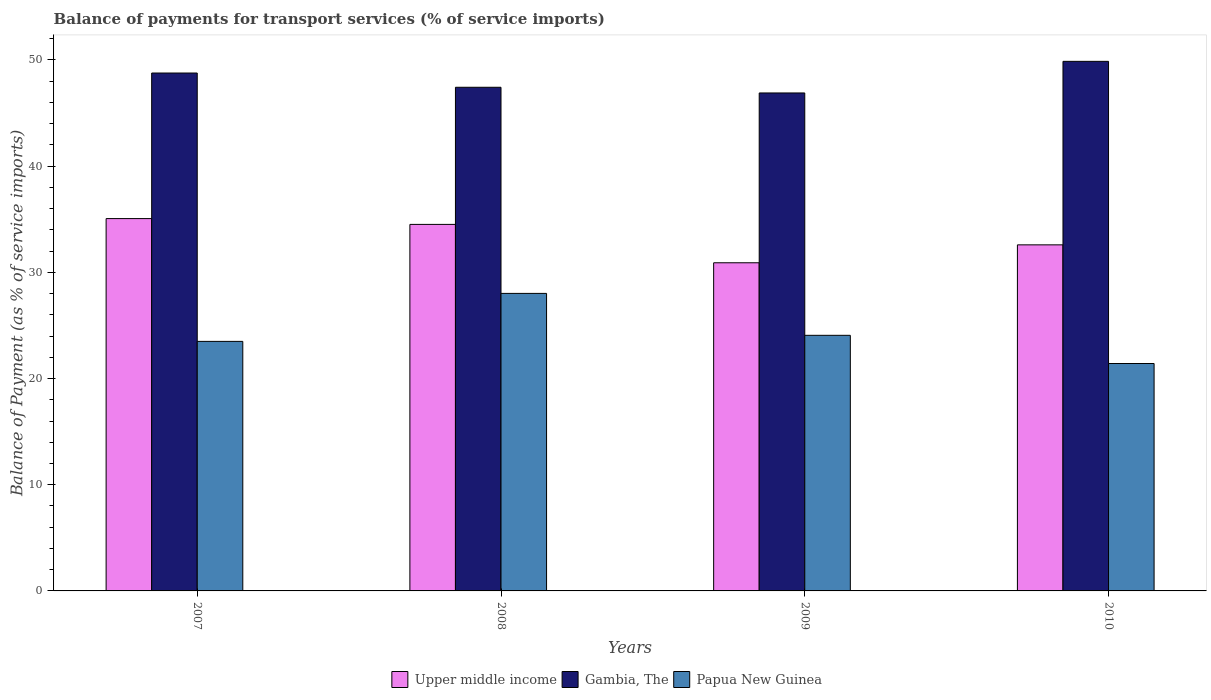How many groups of bars are there?
Offer a very short reply. 4. Are the number of bars per tick equal to the number of legend labels?
Ensure brevity in your answer.  Yes. How many bars are there on the 2nd tick from the left?
Ensure brevity in your answer.  3. What is the balance of payments for transport services in Upper middle income in 2007?
Give a very brief answer. 35.06. Across all years, what is the maximum balance of payments for transport services in Gambia, The?
Keep it short and to the point. 49.87. Across all years, what is the minimum balance of payments for transport services in Gambia, The?
Give a very brief answer. 46.89. In which year was the balance of payments for transport services in Upper middle income minimum?
Keep it short and to the point. 2009. What is the total balance of payments for transport services in Papua New Guinea in the graph?
Ensure brevity in your answer.  97. What is the difference between the balance of payments for transport services in Papua New Guinea in 2007 and that in 2010?
Give a very brief answer. 2.08. What is the difference between the balance of payments for transport services in Upper middle income in 2008 and the balance of payments for transport services in Gambia, The in 2007?
Provide a short and direct response. -14.25. What is the average balance of payments for transport services in Gambia, The per year?
Give a very brief answer. 48.24. In the year 2010, what is the difference between the balance of payments for transport services in Upper middle income and balance of payments for transport services in Gambia, The?
Ensure brevity in your answer.  -17.28. In how many years, is the balance of payments for transport services in Papua New Guinea greater than 42 %?
Make the answer very short. 0. What is the ratio of the balance of payments for transport services in Gambia, The in 2009 to that in 2010?
Keep it short and to the point. 0.94. Is the balance of payments for transport services in Upper middle income in 2007 less than that in 2008?
Offer a terse response. No. What is the difference between the highest and the second highest balance of payments for transport services in Upper middle income?
Keep it short and to the point. 0.55. What is the difference between the highest and the lowest balance of payments for transport services in Upper middle income?
Keep it short and to the point. 4.16. In how many years, is the balance of payments for transport services in Gambia, The greater than the average balance of payments for transport services in Gambia, The taken over all years?
Your answer should be very brief. 2. What does the 3rd bar from the left in 2010 represents?
Keep it short and to the point. Papua New Guinea. What does the 3rd bar from the right in 2008 represents?
Provide a short and direct response. Upper middle income. Is it the case that in every year, the sum of the balance of payments for transport services in Upper middle income and balance of payments for transport services in Gambia, The is greater than the balance of payments for transport services in Papua New Guinea?
Your response must be concise. Yes. How many bars are there?
Provide a succinct answer. 12. Are all the bars in the graph horizontal?
Your response must be concise. No. How many years are there in the graph?
Give a very brief answer. 4. Are the values on the major ticks of Y-axis written in scientific E-notation?
Make the answer very short. No. Where does the legend appear in the graph?
Offer a very short reply. Bottom center. How many legend labels are there?
Offer a very short reply. 3. What is the title of the graph?
Ensure brevity in your answer.  Balance of payments for transport services (% of service imports). Does "Suriname" appear as one of the legend labels in the graph?
Make the answer very short. No. What is the label or title of the Y-axis?
Your response must be concise. Balance of Payment (as % of service imports). What is the Balance of Payment (as % of service imports) of Upper middle income in 2007?
Give a very brief answer. 35.06. What is the Balance of Payment (as % of service imports) in Gambia, The in 2007?
Your response must be concise. 48.77. What is the Balance of Payment (as % of service imports) of Papua New Guinea in 2007?
Your answer should be compact. 23.5. What is the Balance of Payment (as % of service imports) in Upper middle income in 2008?
Make the answer very short. 34.51. What is the Balance of Payment (as % of service imports) of Gambia, The in 2008?
Offer a very short reply. 47.43. What is the Balance of Payment (as % of service imports) of Papua New Guinea in 2008?
Keep it short and to the point. 28.02. What is the Balance of Payment (as % of service imports) of Upper middle income in 2009?
Your answer should be very brief. 30.9. What is the Balance of Payment (as % of service imports) in Gambia, The in 2009?
Ensure brevity in your answer.  46.89. What is the Balance of Payment (as % of service imports) in Papua New Guinea in 2009?
Make the answer very short. 24.07. What is the Balance of Payment (as % of service imports) in Upper middle income in 2010?
Provide a succinct answer. 32.59. What is the Balance of Payment (as % of service imports) in Gambia, The in 2010?
Offer a terse response. 49.87. What is the Balance of Payment (as % of service imports) in Papua New Guinea in 2010?
Offer a terse response. 21.41. Across all years, what is the maximum Balance of Payment (as % of service imports) of Upper middle income?
Your answer should be compact. 35.06. Across all years, what is the maximum Balance of Payment (as % of service imports) in Gambia, The?
Your response must be concise. 49.87. Across all years, what is the maximum Balance of Payment (as % of service imports) in Papua New Guinea?
Your answer should be very brief. 28.02. Across all years, what is the minimum Balance of Payment (as % of service imports) of Upper middle income?
Offer a very short reply. 30.9. Across all years, what is the minimum Balance of Payment (as % of service imports) in Gambia, The?
Provide a succinct answer. 46.89. Across all years, what is the minimum Balance of Payment (as % of service imports) in Papua New Guinea?
Give a very brief answer. 21.41. What is the total Balance of Payment (as % of service imports) in Upper middle income in the graph?
Your answer should be compact. 133.06. What is the total Balance of Payment (as % of service imports) in Gambia, The in the graph?
Provide a short and direct response. 192.95. What is the total Balance of Payment (as % of service imports) in Papua New Guinea in the graph?
Make the answer very short. 97. What is the difference between the Balance of Payment (as % of service imports) of Upper middle income in 2007 and that in 2008?
Ensure brevity in your answer.  0.55. What is the difference between the Balance of Payment (as % of service imports) of Gambia, The in 2007 and that in 2008?
Keep it short and to the point. 1.34. What is the difference between the Balance of Payment (as % of service imports) in Papua New Guinea in 2007 and that in 2008?
Provide a succinct answer. -4.52. What is the difference between the Balance of Payment (as % of service imports) of Upper middle income in 2007 and that in 2009?
Offer a terse response. 4.16. What is the difference between the Balance of Payment (as % of service imports) in Gambia, The in 2007 and that in 2009?
Your answer should be very brief. 1.88. What is the difference between the Balance of Payment (as % of service imports) in Papua New Guinea in 2007 and that in 2009?
Offer a very short reply. -0.57. What is the difference between the Balance of Payment (as % of service imports) of Upper middle income in 2007 and that in 2010?
Make the answer very short. 2.47. What is the difference between the Balance of Payment (as % of service imports) of Gambia, The in 2007 and that in 2010?
Give a very brief answer. -1.1. What is the difference between the Balance of Payment (as % of service imports) of Papua New Guinea in 2007 and that in 2010?
Make the answer very short. 2.08. What is the difference between the Balance of Payment (as % of service imports) in Upper middle income in 2008 and that in 2009?
Offer a terse response. 3.61. What is the difference between the Balance of Payment (as % of service imports) of Gambia, The in 2008 and that in 2009?
Keep it short and to the point. 0.54. What is the difference between the Balance of Payment (as % of service imports) of Papua New Guinea in 2008 and that in 2009?
Ensure brevity in your answer.  3.95. What is the difference between the Balance of Payment (as % of service imports) of Upper middle income in 2008 and that in 2010?
Offer a terse response. 1.93. What is the difference between the Balance of Payment (as % of service imports) in Gambia, The in 2008 and that in 2010?
Keep it short and to the point. -2.44. What is the difference between the Balance of Payment (as % of service imports) of Papua New Guinea in 2008 and that in 2010?
Your response must be concise. 6.6. What is the difference between the Balance of Payment (as % of service imports) in Upper middle income in 2009 and that in 2010?
Your response must be concise. -1.69. What is the difference between the Balance of Payment (as % of service imports) in Gambia, The in 2009 and that in 2010?
Your response must be concise. -2.98. What is the difference between the Balance of Payment (as % of service imports) in Papua New Guinea in 2009 and that in 2010?
Give a very brief answer. 2.65. What is the difference between the Balance of Payment (as % of service imports) in Upper middle income in 2007 and the Balance of Payment (as % of service imports) in Gambia, The in 2008?
Your answer should be compact. -12.37. What is the difference between the Balance of Payment (as % of service imports) in Upper middle income in 2007 and the Balance of Payment (as % of service imports) in Papua New Guinea in 2008?
Provide a short and direct response. 7.04. What is the difference between the Balance of Payment (as % of service imports) in Gambia, The in 2007 and the Balance of Payment (as % of service imports) in Papua New Guinea in 2008?
Keep it short and to the point. 20.75. What is the difference between the Balance of Payment (as % of service imports) of Upper middle income in 2007 and the Balance of Payment (as % of service imports) of Gambia, The in 2009?
Offer a terse response. -11.83. What is the difference between the Balance of Payment (as % of service imports) in Upper middle income in 2007 and the Balance of Payment (as % of service imports) in Papua New Guinea in 2009?
Your answer should be compact. 10.99. What is the difference between the Balance of Payment (as % of service imports) in Gambia, The in 2007 and the Balance of Payment (as % of service imports) in Papua New Guinea in 2009?
Make the answer very short. 24.7. What is the difference between the Balance of Payment (as % of service imports) of Upper middle income in 2007 and the Balance of Payment (as % of service imports) of Gambia, The in 2010?
Provide a succinct answer. -14.81. What is the difference between the Balance of Payment (as % of service imports) of Upper middle income in 2007 and the Balance of Payment (as % of service imports) of Papua New Guinea in 2010?
Provide a short and direct response. 13.65. What is the difference between the Balance of Payment (as % of service imports) in Gambia, The in 2007 and the Balance of Payment (as % of service imports) in Papua New Guinea in 2010?
Make the answer very short. 27.35. What is the difference between the Balance of Payment (as % of service imports) of Upper middle income in 2008 and the Balance of Payment (as % of service imports) of Gambia, The in 2009?
Your answer should be compact. -12.38. What is the difference between the Balance of Payment (as % of service imports) of Upper middle income in 2008 and the Balance of Payment (as % of service imports) of Papua New Guinea in 2009?
Provide a short and direct response. 10.45. What is the difference between the Balance of Payment (as % of service imports) in Gambia, The in 2008 and the Balance of Payment (as % of service imports) in Papua New Guinea in 2009?
Your answer should be compact. 23.36. What is the difference between the Balance of Payment (as % of service imports) of Upper middle income in 2008 and the Balance of Payment (as % of service imports) of Gambia, The in 2010?
Offer a very short reply. -15.35. What is the difference between the Balance of Payment (as % of service imports) in Upper middle income in 2008 and the Balance of Payment (as % of service imports) in Papua New Guinea in 2010?
Your response must be concise. 13.1. What is the difference between the Balance of Payment (as % of service imports) in Gambia, The in 2008 and the Balance of Payment (as % of service imports) in Papua New Guinea in 2010?
Your answer should be compact. 26.01. What is the difference between the Balance of Payment (as % of service imports) of Upper middle income in 2009 and the Balance of Payment (as % of service imports) of Gambia, The in 2010?
Keep it short and to the point. -18.97. What is the difference between the Balance of Payment (as % of service imports) of Upper middle income in 2009 and the Balance of Payment (as % of service imports) of Papua New Guinea in 2010?
Your answer should be compact. 9.49. What is the difference between the Balance of Payment (as % of service imports) in Gambia, The in 2009 and the Balance of Payment (as % of service imports) in Papua New Guinea in 2010?
Give a very brief answer. 25.48. What is the average Balance of Payment (as % of service imports) of Upper middle income per year?
Ensure brevity in your answer.  33.27. What is the average Balance of Payment (as % of service imports) of Gambia, The per year?
Offer a very short reply. 48.24. What is the average Balance of Payment (as % of service imports) in Papua New Guinea per year?
Provide a succinct answer. 24.25. In the year 2007, what is the difference between the Balance of Payment (as % of service imports) in Upper middle income and Balance of Payment (as % of service imports) in Gambia, The?
Your response must be concise. -13.71. In the year 2007, what is the difference between the Balance of Payment (as % of service imports) in Upper middle income and Balance of Payment (as % of service imports) in Papua New Guinea?
Offer a terse response. 11.56. In the year 2007, what is the difference between the Balance of Payment (as % of service imports) of Gambia, The and Balance of Payment (as % of service imports) of Papua New Guinea?
Make the answer very short. 25.27. In the year 2008, what is the difference between the Balance of Payment (as % of service imports) of Upper middle income and Balance of Payment (as % of service imports) of Gambia, The?
Provide a succinct answer. -12.91. In the year 2008, what is the difference between the Balance of Payment (as % of service imports) of Upper middle income and Balance of Payment (as % of service imports) of Papua New Guinea?
Your answer should be very brief. 6.5. In the year 2008, what is the difference between the Balance of Payment (as % of service imports) of Gambia, The and Balance of Payment (as % of service imports) of Papua New Guinea?
Your answer should be compact. 19.41. In the year 2009, what is the difference between the Balance of Payment (as % of service imports) of Upper middle income and Balance of Payment (as % of service imports) of Gambia, The?
Your answer should be very brief. -15.99. In the year 2009, what is the difference between the Balance of Payment (as % of service imports) of Upper middle income and Balance of Payment (as % of service imports) of Papua New Guinea?
Your response must be concise. 6.83. In the year 2009, what is the difference between the Balance of Payment (as % of service imports) in Gambia, The and Balance of Payment (as % of service imports) in Papua New Guinea?
Ensure brevity in your answer.  22.82. In the year 2010, what is the difference between the Balance of Payment (as % of service imports) in Upper middle income and Balance of Payment (as % of service imports) in Gambia, The?
Provide a succinct answer. -17.28. In the year 2010, what is the difference between the Balance of Payment (as % of service imports) of Upper middle income and Balance of Payment (as % of service imports) of Papua New Guinea?
Give a very brief answer. 11.17. In the year 2010, what is the difference between the Balance of Payment (as % of service imports) of Gambia, The and Balance of Payment (as % of service imports) of Papua New Guinea?
Your response must be concise. 28.45. What is the ratio of the Balance of Payment (as % of service imports) in Upper middle income in 2007 to that in 2008?
Provide a succinct answer. 1.02. What is the ratio of the Balance of Payment (as % of service imports) in Gambia, The in 2007 to that in 2008?
Your answer should be compact. 1.03. What is the ratio of the Balance of Payment (as % of service imports) of Papua New Guinea in 2007 to that in 2008?
Provide a succinct answer. 0.84. What is the ratio of the Balance of Payment (as % of service imports) of Upper middle income in 2007 to that in 2009?
Offer a terse response. 1.13. What is the ratio of the Balance of Payment (as % of service imports) in Papua New Guinea in 2007 to that in 2009?
Offer a terse response. 0.98. What is the ratio of the Balance of Payment (as % of service imports) of Upper middle income in 2007 to that in 2010?
Your answer should be compact. 1.08. What is the ratio of the Balance of Payment (as % of service imports) in Papua New Guinea in 2007 to that in 2010?
Provide a short and direct response. 1.1. What is the ratio of the Balance of Payment (as % of service imports) of Upper middle income in 2008 to that in 2009?
Your response must be concise. 1.12. What is the ratio of the Balance of Payment (as % of service imports) of Gambia, The in 2008 to that in 2009?
Offer a terse response. 1.01. What is the ratio of the Balance of Payment (as % of service imports) in Papua New Guinea in 2008 to that in 2009?
Offer a terse response. 1.16. What is the ratio of the Balance of Payment (as % of service imports) of Upper middle income in 2008 to that in 2010?
Provide a short and direct response. 1.06. What is the ratio of the Balance of Payment (as % of service imports) of Gambia, The in 2008 to that in 2010?
Keep it short and to the point. 0.95. What is the ratio of the Balance of Payment (as % of service imports) in Papua New Guinea in 2008 to that in 2010?
Offer a terse response. 1.31. What is the ratio of the Balance of Payment (as % of service imports) in Upper middle income in 2009 to that in 2010?
Ensure brevity in your answer.  0.95. What is the ratio of the Balance of Payment (as % of service imports) in Gambia, The in 2009 to that in 2010?
Provide a succinct answer. 0.94. What is the ratio of the Balance of Payment (as % of service imports) in Papua New Guinea in 2009 to that in 2010?
Offer a terse response. 1.12. What is the difference between the highest and the second highest Balance of Payment (as % of service imports) in Upper middle income?
Provide a succinct answer. 0.55. What is the difference between the highest and the second highest Balance of Payment (as % of service imports) of Gambia, The?
Make the answer very short. 1.1. What is the difference between the highest and the second highest Balance of Payment (as % of service imports) of Papua New Guinea?
Provide a succinct answer. 3.95. What is the difference between the highest and the lowest Balance of Payment (as % of service imports) of Upper middle income?
Provide a succinct answer. 4.16. What is the difference between the highest and the lowest Balance of Payment (as % of service imports) of Gambia, The?
Your answer should be very brief. 2.98. What is the difference between the highest and the lowest Balance of Payment (as % of service imports) of Papua New Guinea?
Your answer should be very brief. 6.6. 